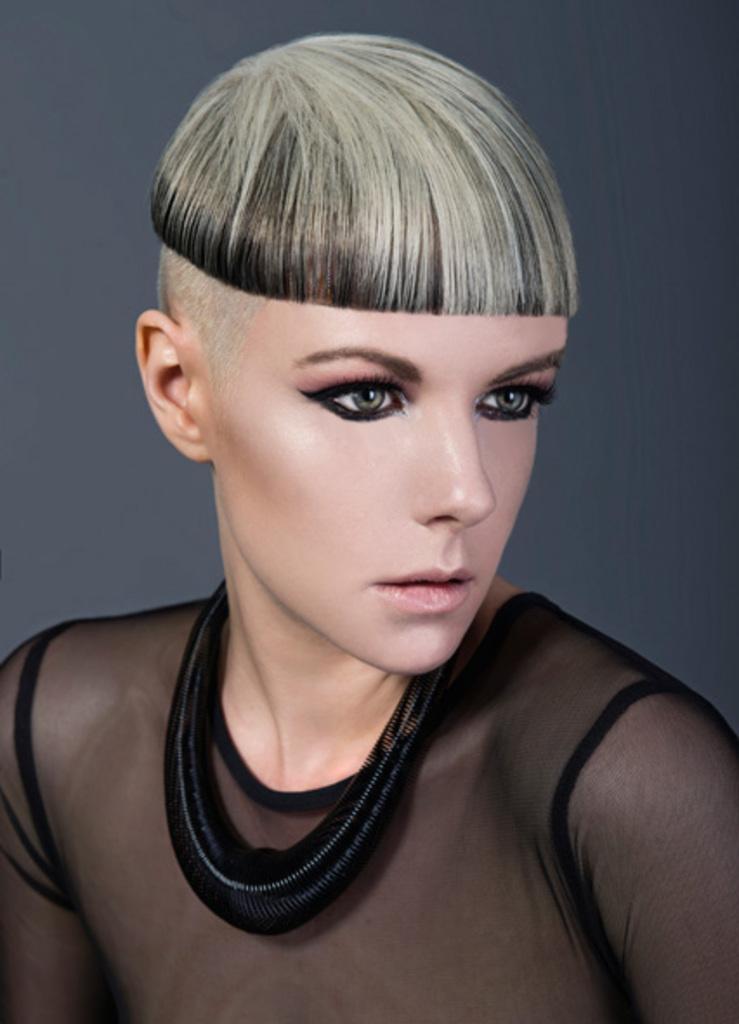How would you summarize this image in a sentence or two? In this image I can see a woman in the front, I can see she is wearing black colour dress and around her neck I can see a black colour thing. 